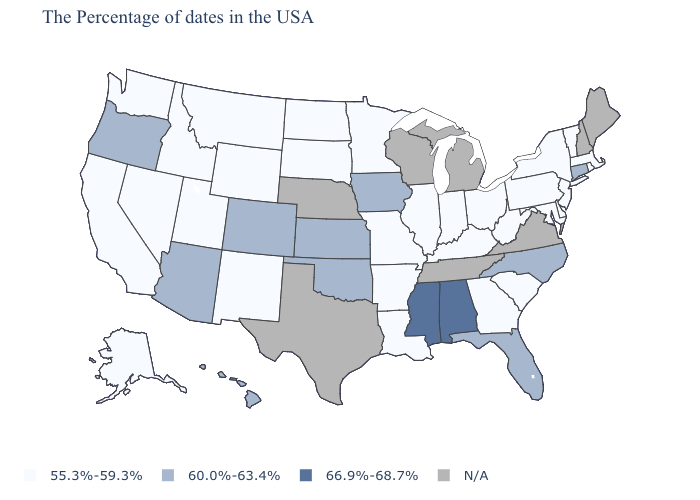What is the value of Minnesota?
Be succinct. 55.3%-59.3%. How many symbols are there in the legend?
Quick response, please. 4. What is the lowest value in the West?
Answer briefly. 55.3%-59.3%. Among the states that border New Jersey , which have the highest value?
Answer briefly. New York, Delaware, Pennsylvania. What is the highest value in the USA?
Write a very short answer. 66.9%-68.7%. What is the value of Arizona?
Quick response, please. 60.0%-63.4%. Name the states that have a value in the range 55.3%-59.3%?
Answer briefly. Massachusetts, Rhode Island, Vermont, New York, New Jersey, Delaware, Maryland, Pennsylvania, South Carolina, West Virginia, Ohio, Georgia, Kentucky, Indiana, Illinois, Louisiana, Missouri, Arkansas, Minnesota, South Dakota, North Dakota, Wyoming, New Mexico, Utah, Montana, Idaho, Nevada, California, Washington, Alaska. Name the states that have a value in the range 66.9%-68.7%?
Be succinct. Alabama, Mississippi. Name the states that have a value in the range N/A?
Give a very brief answer. Maine, New Hampshire, Virginia, Michigan, Tennessee, Wisconsin, Nebraska, Texas. How many symbols are there in the legend?
Concise answer only. 4. Name the states that have a value in the range N/A?
Quick response, please. Maine, New Hampshire, Virginia, Michigan, Tennessee, Wisconsin, Nebraska, Texas. What is the value of Maine?
Be succinct. N/A. Which states have the lowest value in the USA?
Write a very short answer. Massachusetts, Rhode Island, Vermont, New York, New Jersey, Delaware, Maryland, Pennsylvania, South Carolina, West Virginia, Ohio, Georgia, Kentucky, Indiana, Illinois, Louisiana, Missouri, Arkansas, Minnesota, South Dakota, North Dakota, Wyoming, New Mexico, Utah, Montana, Idaho, Nevada, California, Washington, Alaska. Name the states that have a value in the range N/A?
Write a very short answer. Maine, New Hampshire, Virginia, Michigan, Tennessee, Wisconsin, Nebraska, Texas. What is the value of Mississippi?
Write a very short answer. 66.9%-68.7%. 